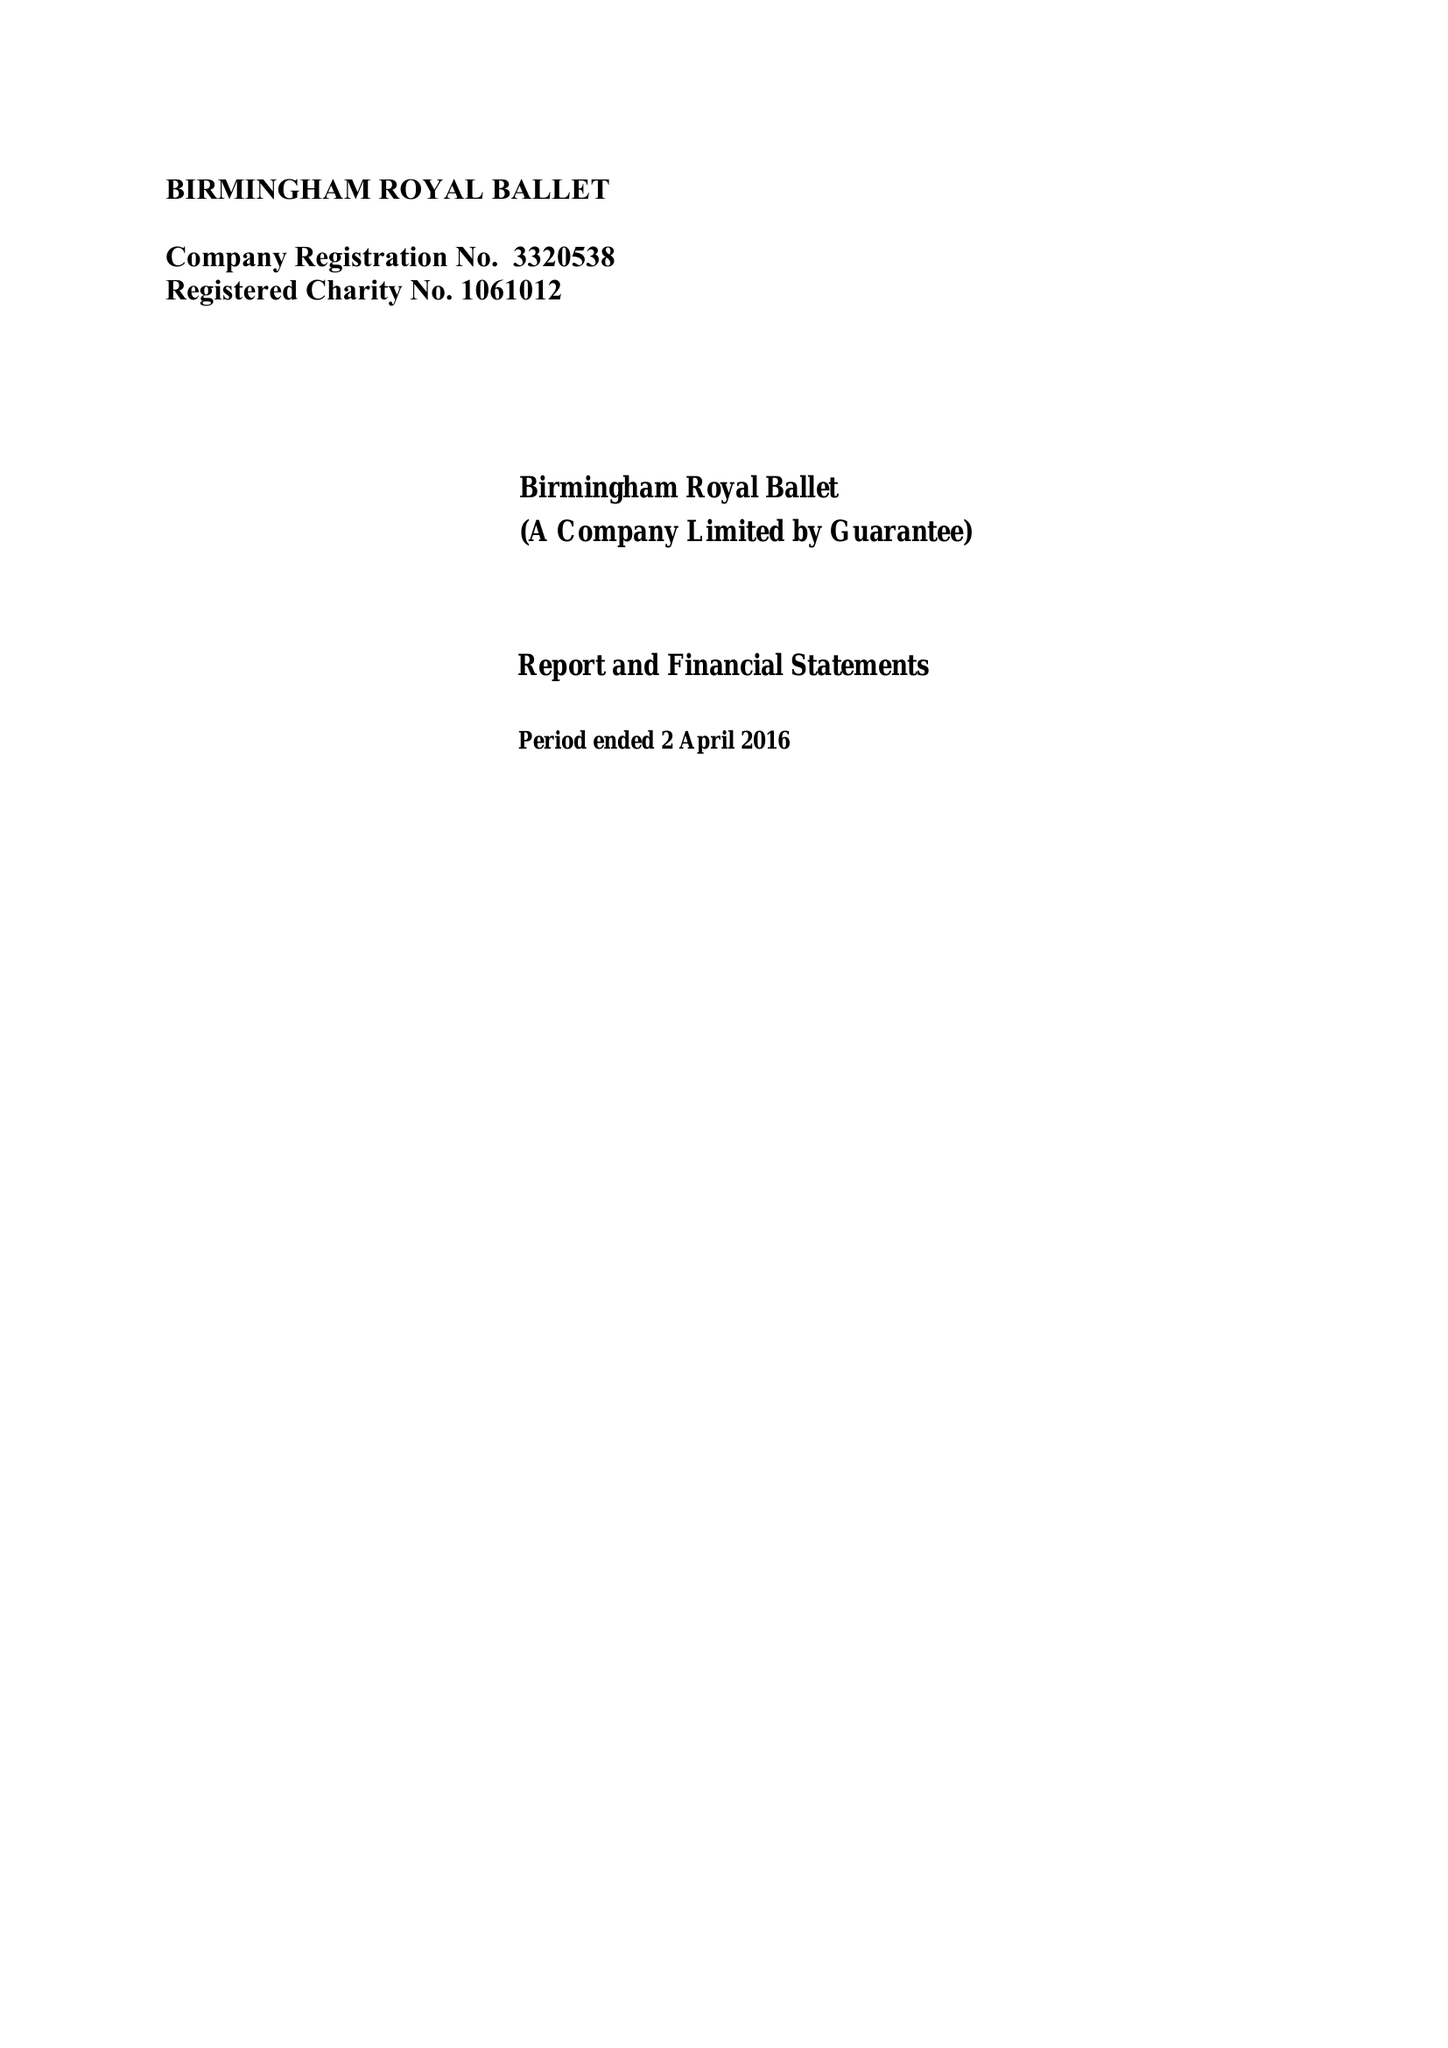What is the value for the charity_name?
Answer the question using a single word or phrase. Birmingham Royal Ballet 